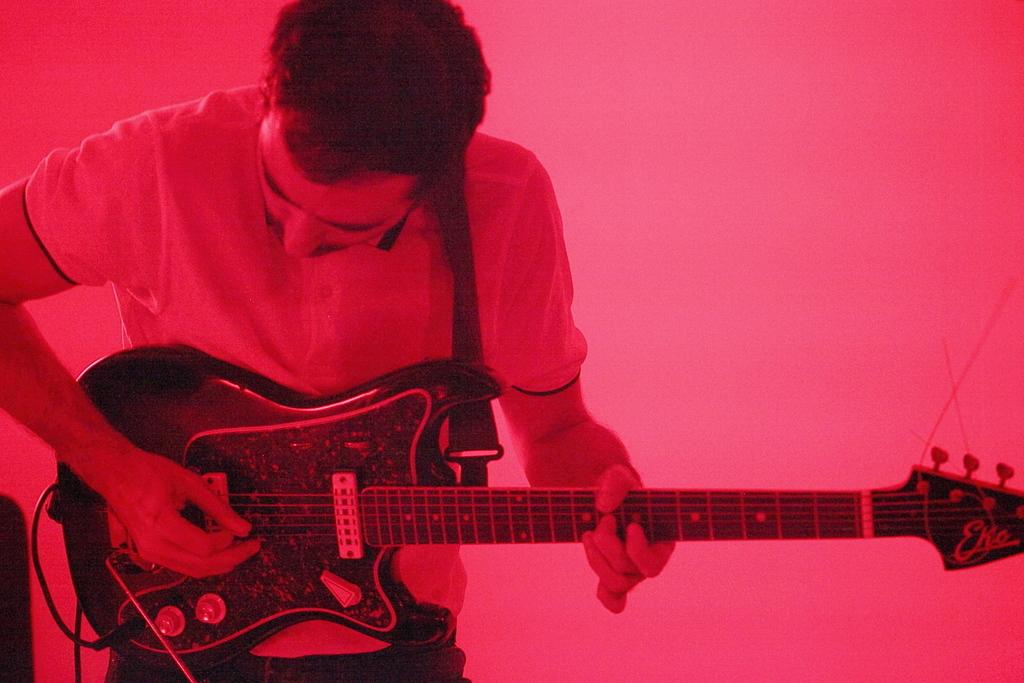What is the main subject of the image? The main subject of the image is a man. What is the man doing in the image? The man is standing and playing a guitar. Can you describe any additional details about the image? There is a cable visible in the image. Can you see the man's friend playing a low note on the seashore in the image? There is no friend, low note, or seashore present in the image. 